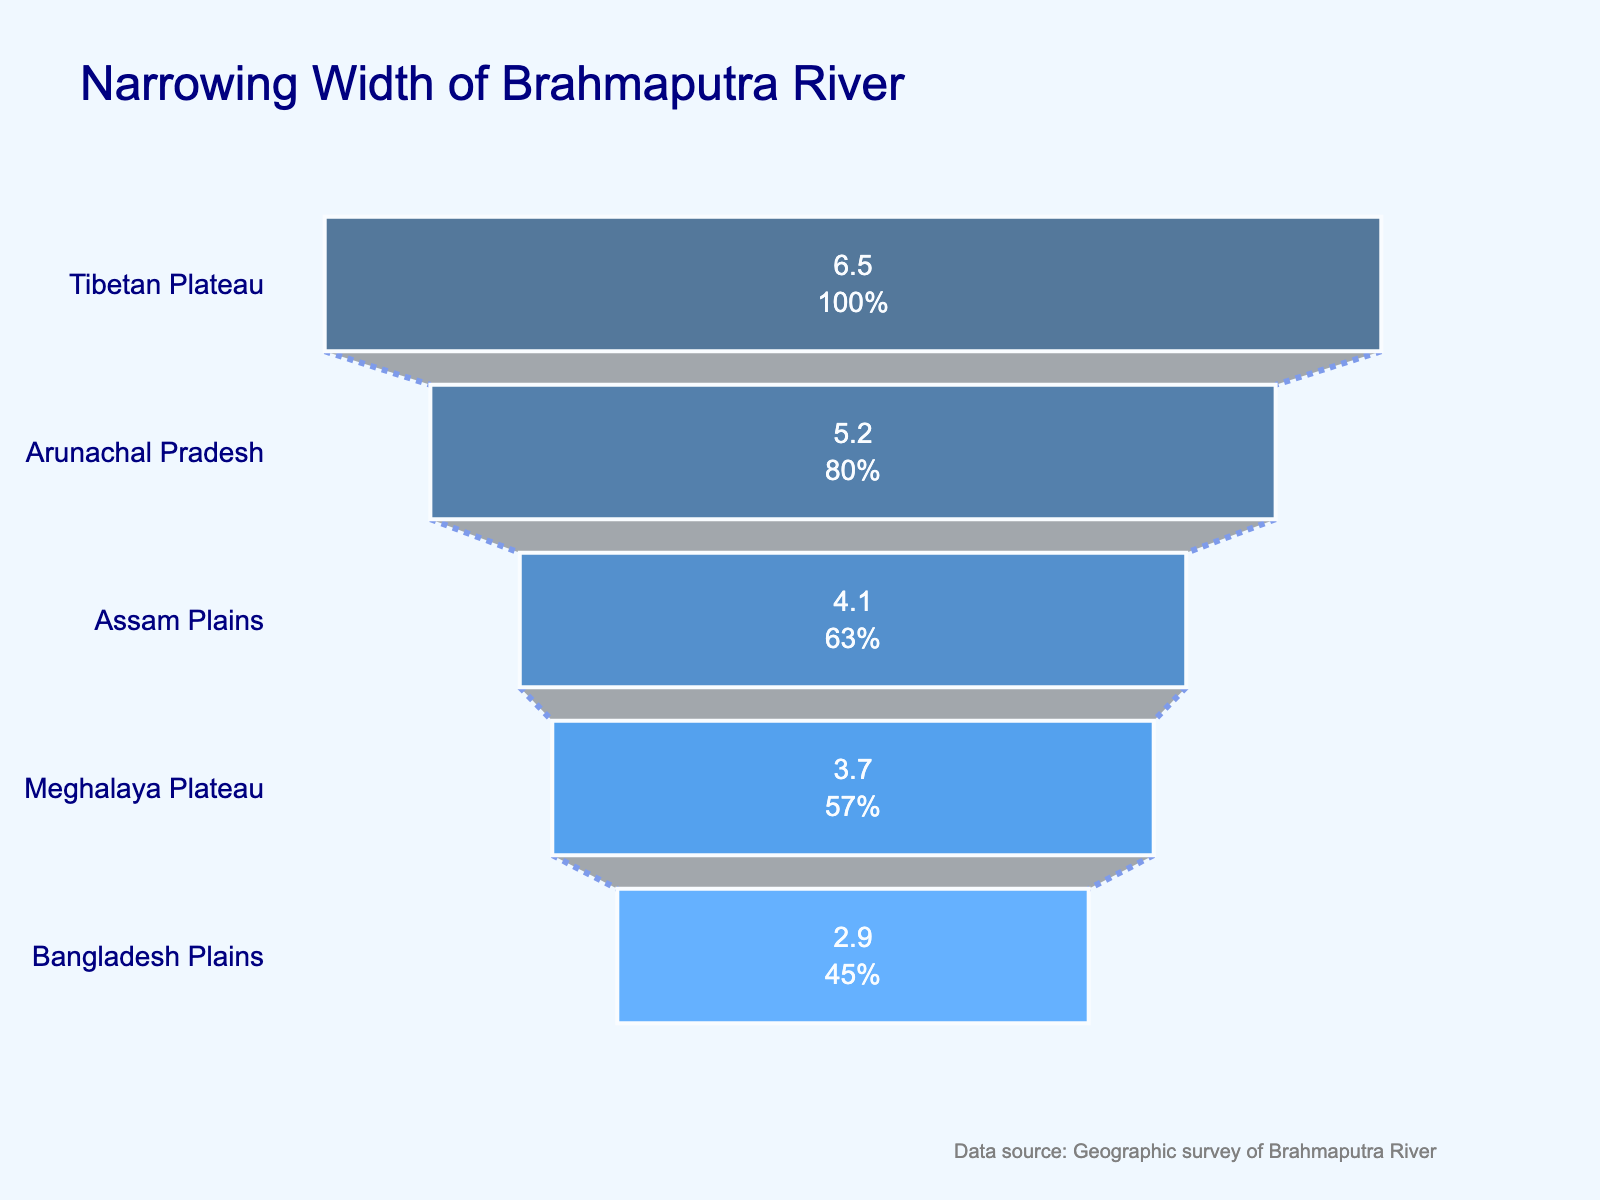what is the title of the figure? The title of the figure is often prominently displayed at the top center. In this case, it reads "Narrowing Width of Brahmaputra River".
Answer: Narrowing Width of Brahmaputra River how many data points are there in the chart? To determine the number of data points, count the number of regions listed on the y-axis. Here, we have five regions.
Answer: 5 which region shows the narrowest width for the Brahmaputra River? By observing the width values on the x-axis, the region with the smallest width should be noted. In this case, "Bangladesh Plains" has the narrowest width of 2.9 km.
Answer: Bangladesh Plains what is the width of the Brahmaputra River in the Assam Plains? Locate the "Assam Plains" on the y-axis and refer to its corresponding width on the x-axis. The width here is 4.1 km.
Answer: 4.1 km how does the width of the river change from Arunachal Pradesh to Assam Plains? Subtract the width of "Assam Plains" from "Arunachal Pradesh" to find the difference: 5.2 km - 4.1 km = 1.1 km. The river narrows by 1.1 km.
Answer: The river narrows by 1.1 km which regions have river widths greater than 3 km but less than 5 km? Identify regions whose widths fall within the range 3 km to 5 km. Here, both "Assam Plains" (4.1 km) and "Meghalaya Plateau" (3.7 km) match this criteria.
Answer: Assam Plains and Meghalaya Plateau what is the percentage decrease in river width from Tibet to Bangladesh Plains? Calculate the percentage decrease: (Initial value - Final value) / Initial value * 100. Thus, (6.5 - 2.9) / 6.5 * 100 ≈ 55.38%.
Answer: 55.38% how much wider is the river in the Tibetan Plateau compared to the Meghalaya Plateau? Subtract the width of "Meghalaya Plateau" from "Tibetan Plateau" to find the difference: 6.5 km - 3.7 km = 2.8 km.
Answer: 2.8 km which region experiences the most significant narrowing of the river's width? Identify the region pair that has the greatest width change. The difference between "Tibetan Plateau" (6.5 km) and "Arunachal Pradesh" (5.2 km) is 1.3 km, the largest among the given data points.
Answer: Tibetan Plateau to Arunachal Pradesh what is the average width of the river across all regions listed? Sum the widths: 6.5 + 5.2 + 4.1 + 3.7 + 2.9 = 22.4 km, then divide by the number of regions: 22.4 / 5 = 4.48 km.
Answer: 4.48 km 